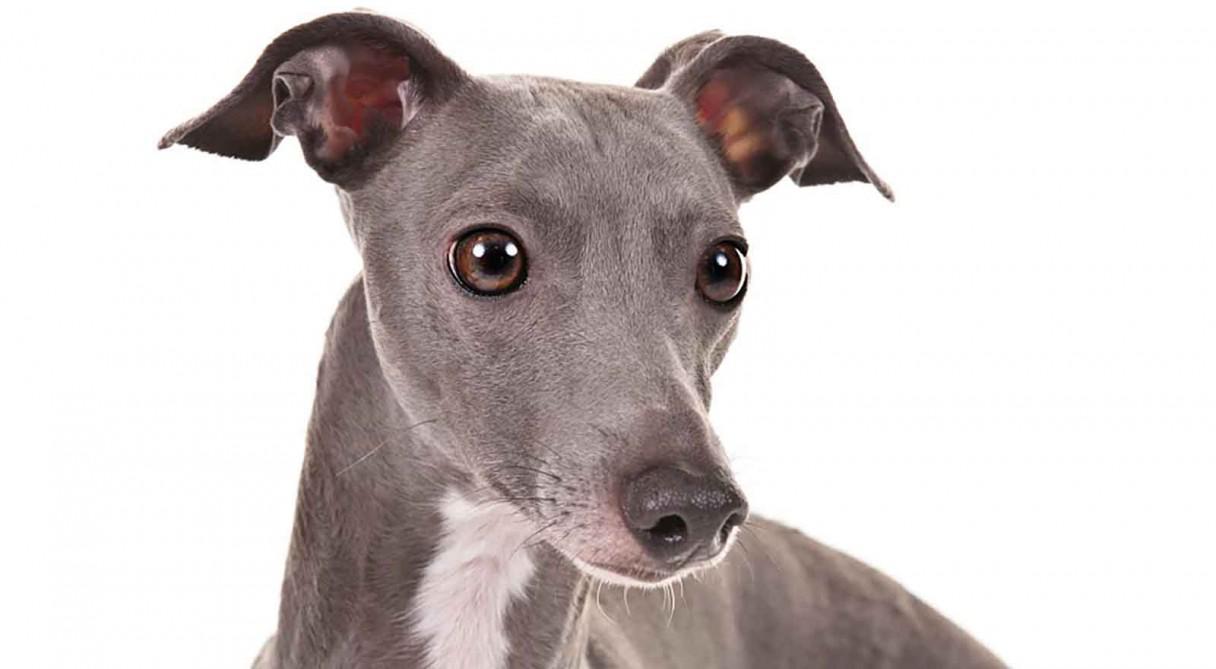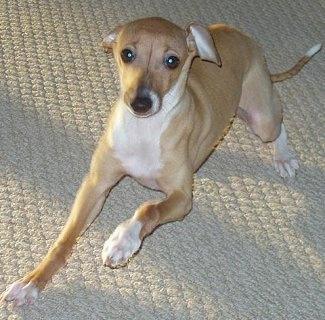The first image is the image on the left, the second image is the image on the right. For the images displayed, is the sentence "An image shows a human limb touching a hound with its tongue hanging to the right." factually correct? Answer yes or no. No. 